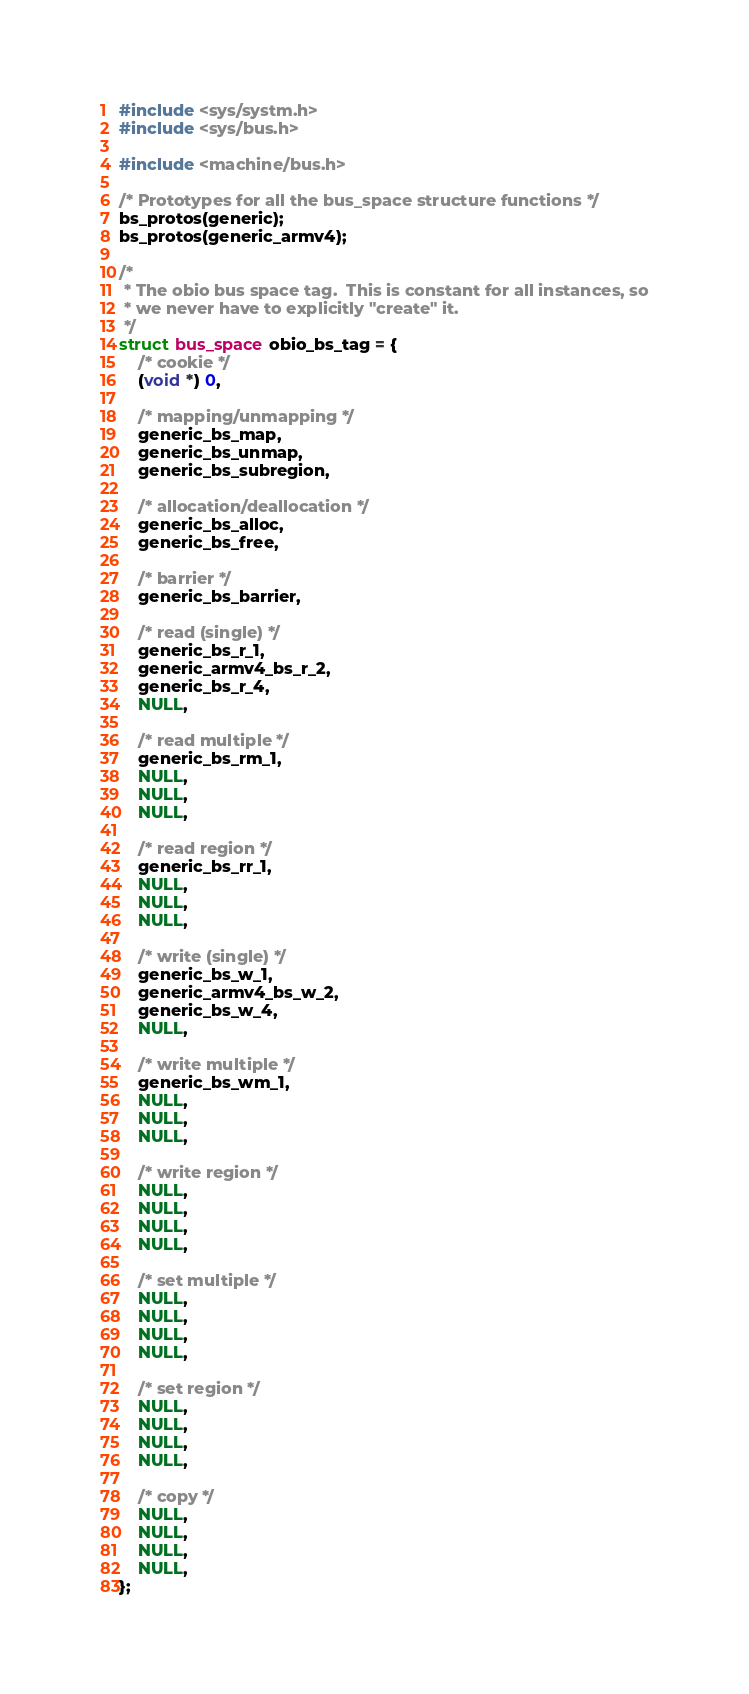<code> <loc_0><loc_0><loc_500><loc_500><_C_>#include <sys/systm.h>
#include <sys/bus.h>

#include <machine/bus.h>

/* Prototypes for all the bus_space structure functions */
bs_protos(generic);
bs_protos(generic_armv4);

/*
 * The obio bus space tag.  This is constant for all instances, so
 * we never have to explicitly "create" it.
 */
struct bus_space obio_bs_tag = {
	/* cookie */
	(void *) 0,

	/* mapping/unmapping */
	generic_bs_map,
	generic_bs_unmap,
	generic_bs_subregion,

	/* allocation/deallocation */
	generic_bs_alloc,
	generic_bs_free,

	/* barrier */
	generic_bs_barrier,

	/* read (single) */
	generic_bs_r_1,
	generic_armv4_bs_r_2,
	generic_bs_r_4,
	NULL,

	/* read multiple */
	generic_bs_rm_1,
	NULL,
	NULL,
	NULL,

	/* read region */
	generic_bs_rr_1,
	NULL,
	NULL,
	NULL,

	/* write (single) */
	generic_bs_w_1,
	generic_armv4_bs_w_2,
	generic_bs_w_4,
	NULL,

	/* write multiple */
	generic_bs_wm_1,
	NULL,
	NULL,
	NULL,

	/* write region */
	NULL,
	NULL,
	NULL,
	NULL,

	/* set multiple */
	NULL,
	NULL,
	NULL,
	NULL,

	/* set region */
	NULL,
	NULL,
	NULL,
	NULL,

	/* copy */
	NULL,
	NULL,
	NULL,
	NULL,
};
</code> 